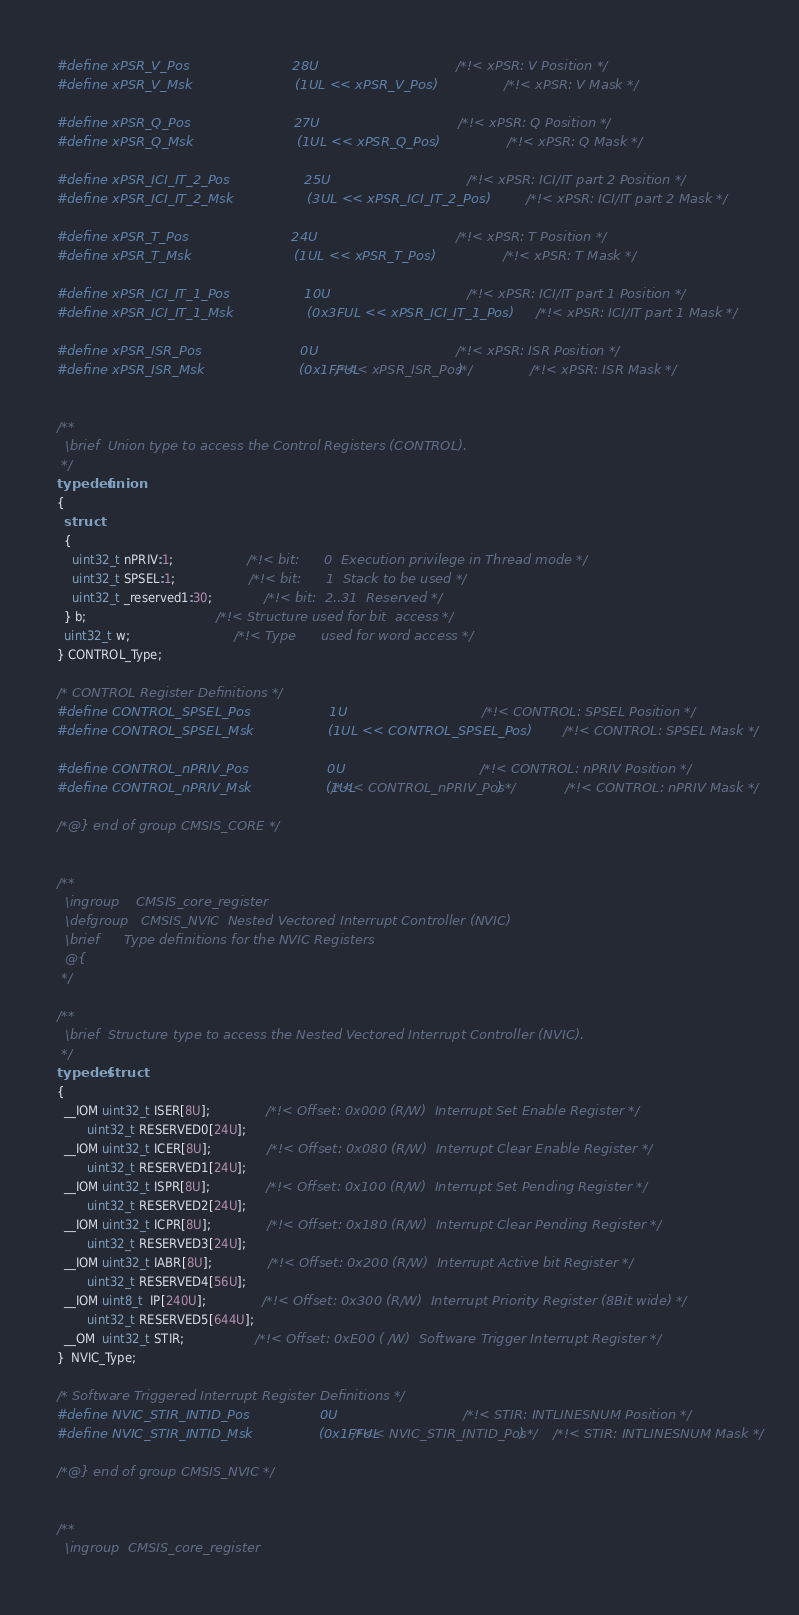<code> <loc_0><loc_0><loc_500><loc_500><_C_>#define xPSR_V_Pos                         28U                                            /*!< xPSR: V Position */
#define xPSR_V_Msk                         (1UL << xPSR_V_Pos)                            /*!< xPSR: V Mask */

#define xPSR_Q_Pos                         27U                                            /*!< xPSR: Q Position */
#define xPSR_Q_Msk                         (1UL << xPSR_Q_Pos)                            /*!< xPSR: Q Mask */

#define xPSR_ICI_IT_2_Pos                  25U                                            /*!< xPSR: ICI/IT part 2 Position */
#define xPSR_ICI_IT_2_Msk                  (3UL << xPSR_ICI_IT_2_Pos)                     /*!< xPSR: ICI/IT part 2 Mask */

#define xPSR_T_Pos                         24U                                            /*!< xPSR: T Position */
#define xPSR_T_Msk                         (1UL << xPSR_T_Pos)                            /*!< xPSR: T Mask */

#define xPSR_ICI_IT_1_Pos                  10U                                            /*!< xPSR: ICI/IT part 1 Position */
#define xPSR_ICI_IT_1_Msk                  (0x3FUL << xPSR_ICI_IT_1_Pos)                  /*!< xPSR: ICI/IT part 1 Mask */

#define xPSR_ISR_Pos                        0U                                            /*!< xPSR: ISR Position */
#define xPSR_ISR_Msk                       (0x1FFUL /*<< xPSR_ISR_Pos*/)                  /*!< xPSR: ISR Mask */


/**
  \brief  Union type to access the Control Registers (CONTROL).
 */
typedef union
{
  struct
  {
    uint32_t nPRIV:1;                    /*!< bit:      0  Execution privilege in Thread mode */
    uint32_t SPSEL:1;                    /*!< bit:      1  Stack to be used */
    uint32_t _reserved1:30;              /*!< bit:  2..31  Reserved */
  } b;                                   /*!< Structure used for bit  access */
  uint32_t w;                            /*!< Type      used for word access */
} CONTROL_Type;

/* CONTROL Register Definitions */
#define CONTROL_SPSEL_Pos                   1U                                            /*!< CONTROL: SPSEL Position */
#define CONTROL_SPSEL_Msk                  (1UL << CONTROL_SPSEL_Pos)                     /*!< CONTROL: SPSEL Mask */

#define CONTROL_nPRIV_Pos                   0U                                            /*!< CONTROL: nPRIV Position */
#define CONTROL_nPRIV_Msk                  (1UL /*<< CONTROL_nPRIV_Pos*/)                 /*!< CONTROL: nPRIV Mask */

/*@} end of group CMSIS_CORE */


/**
  \ingroup    CMSIS_core_register
  \defgroup   CMSIS_NVIC  Nested Vectored Interrupt Controller (NVIC)
  \brief      Type definitions for the NVIC Registers
  @{
 */

/**
  \brief  Structure type to access the Nested Vectored Interrupt Controller (NVIC).
 */
typedef struct
{
  __IOM uint32_t ISER[8U];               /*!< Offset: 0x000 (R/W)  Interrupt Set Enable Register */
        uint32_t RESERVED0[24U];
  __IOM uint32_t ICER[8U];               /*!< Offset: 0x080 (R/W)  Interrupt Clear Enable Register */
        uint32_t RESERVED1[24U];
  __IOM uint32_t ISPR[8U];               /*!< Offset: 0x100 (R/W)  Interrupt Set Pending Register */
        uint32_t RESERVED2[24U];
  __IOM uint32_t ICPR[8U];               /*!< Offset: 0x180 (R/W)  Interrupt Clear Pending Register */
        uint32_t RESERVED3[24U];
  __IOM uint32_t IABR[8U];               /*!< Offset: 0x200 (R/W)  Interrupt Active bit Register */
        uint32_t RESERVED4[56U];
  __IOM uint8_t  IP[240U];               /*!< Offset: 0x300 (R/W)  Interrupt Priority Register (8Bit wide) */
        uint32_t RESERVED5[644U];
  __OM  uint32_t STIR;                   /*!< Offset: 0xE00 ( /W)  Software Trigger Interrupt Register */
}  NVIC_Type;

/* Software Triggered Interrupt Register Definitions */
#define NVIC_STIR_INTID_Pos                 0U                                         /*!< STIR: INTLINESNUM Position */
#define NVIC_STIR_INTID_Msk                (0x1FFUL /*<< NVIC_STIR_INTID_Pos*/)        /*!< STIR: INTLINESNUM Mask */

/*@} end of group CMSIS_NVIC */


/**
  \ingroup  CMSIS_core_register</code> 